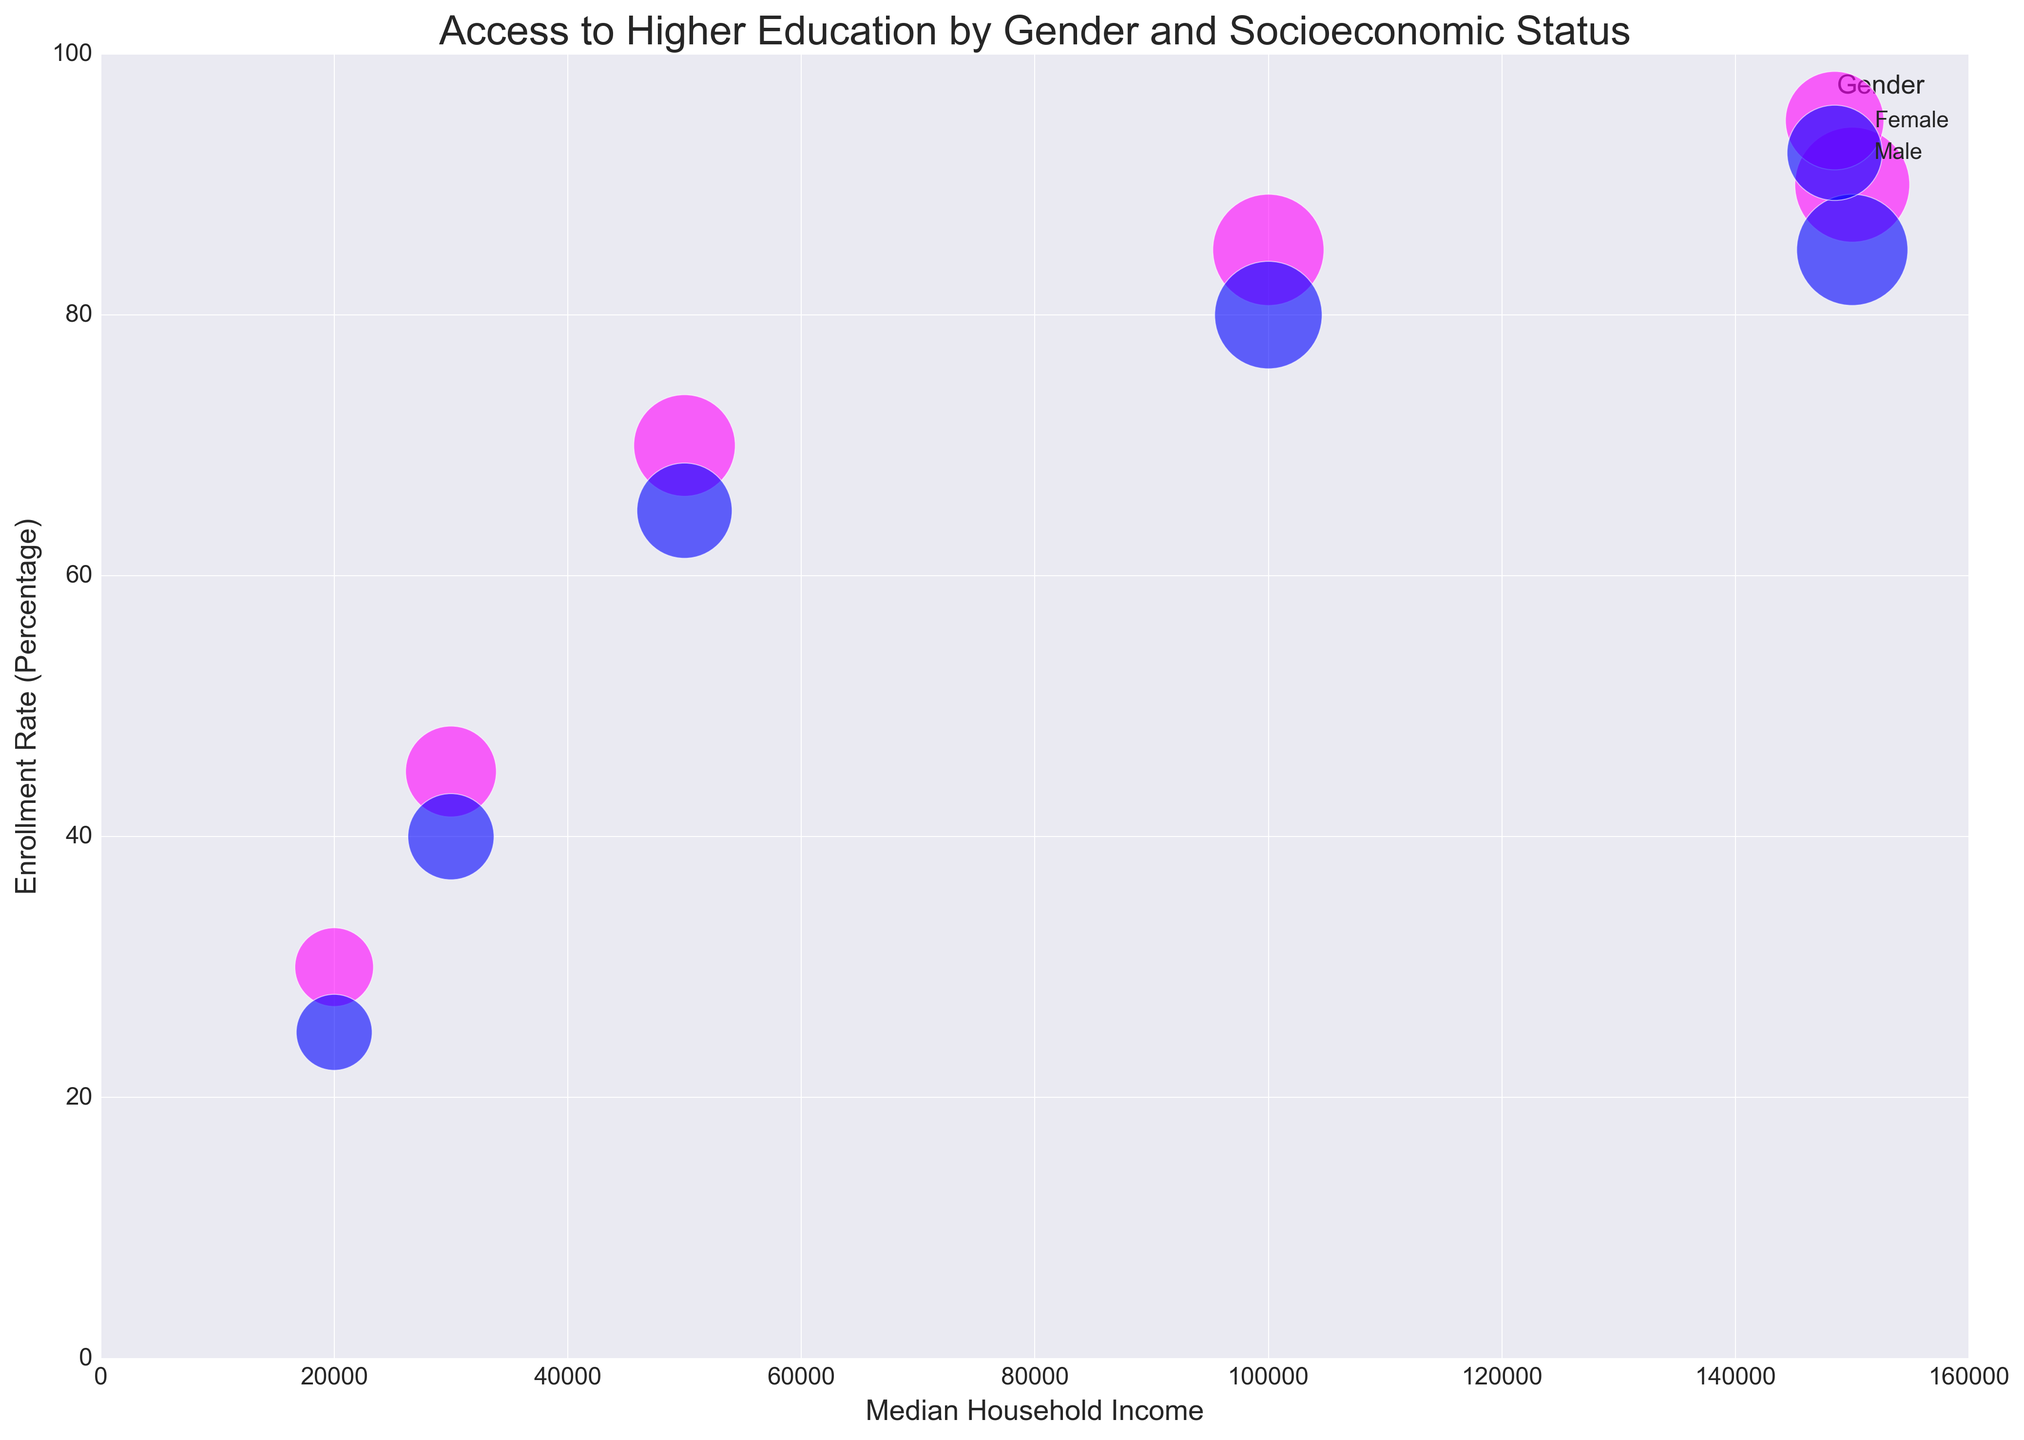What's the enrollment rate for females with very low socioeconomic status? Look for the data points where the gender is female and the socioeconomic status is very low. The enrollment rate associated with this data point is 30%.
Answer: 30% Which gender has the higher enrollment rate at the high socioeconomic status? Compare the enrollment rates for males and females at high socioeconomic status. The enrollment rate for females is 85% and for males is 80%. Thus, females have the higher enrollment rate.
Answer: Female What is the difference in enrollment rates between males and females in the very high socioeconomic status group? Identify the enrollment rates for males and females in the very high socioeconomic status group. For males, it is 85%, and for females, it is 90%. Compute the difference: 90% - 85% = 5%.
Answer: 5% What is the average enrollment rate for males across all socioeconomic statuses? List all the enrollment rates for males: 40%, 65%, 80%, 25%, 85%. Sum these values: 40 + 65 + 80 + 25 + 85 = 295. Then, divide by the number of data points (5): 295 / 5 = 59%.
Answer: 59% Which group has the largest bubble size? Visually inspect the plot for the largest bubble. The largest bubble is for females in the very high socioeconomic status with a size of 3200.
Answer: Female, Very High For the middle socioeconomic status, which gender has a higher enrollment rate? Compare the enrollment rates for the middle socioeconomic status for both genders. Females have an enrollment rate of 70%, while males have 65%. Thus, females have a higher enrollment rate.
Answer: Female How does the enrollment rate for females in low socioeconomic status compare to that of females in high socioeconomic status? Observe that females have a 45% enrollment rate in low socioeconomic status and 85% in high socioeconomic status. Thus, the enrollment rate for females is higher in the high socioeconomic status.
Answer: Higher in high socioeconomic status Describe the color representation in the chart for each gender. The chart uses different colors to represent genders: magenta for females and blue for males. This color-coding helps differentiate the data points visually.
Answer: Magenta for females, blue for males 